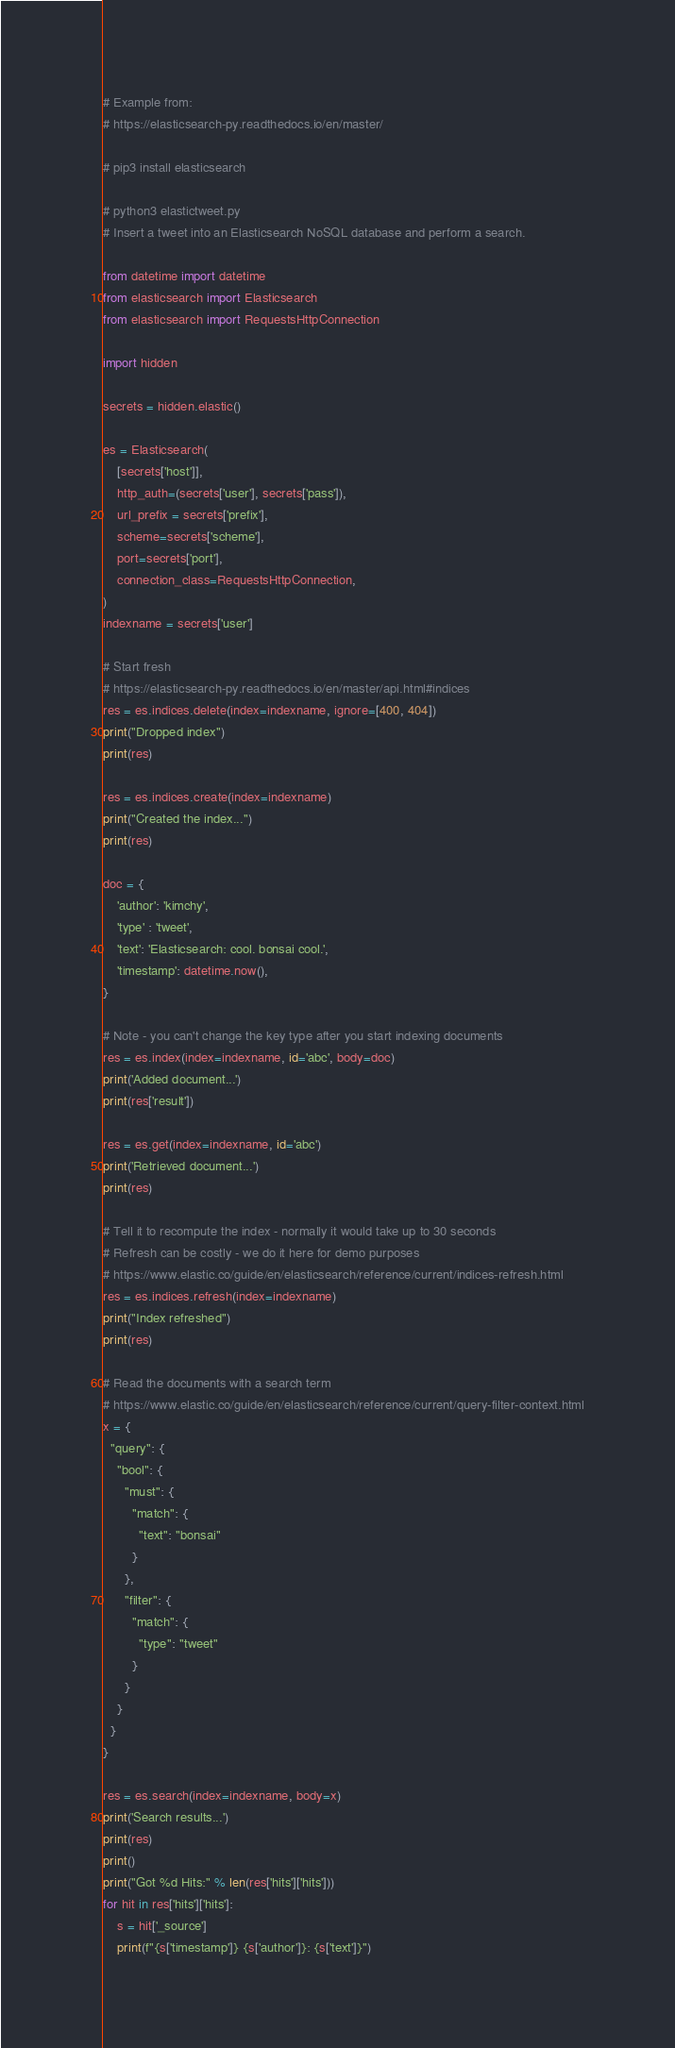<code> <loc_0><loc_0><loc_500><loc_500><_Python_># Example from:
# https://elasticsearch-py.readthedocs.io/en/master/

# pip3 install elasticsearch

# python3 elastictweet.py
# Insert a tweet into an Elasticsearch NoSQL database and perform a search.

from datetime import datetime
from elasticsearch import Elasticsearch
from elasticsearch import RequestsHttpConnection

import hidden

secrets = hidden.elastic()

es = Elasticsearch(
    [secrets['host']],
    http_auth=(secrets['user'], secrets['pass']),
    url_prefix = secrets['prefix'],
    scheme=secrets['scheme'],
    port=secrets['port'],
    connection_class=RequestsHttpConnection,
)
indexname = secrets['user']

# Start fresh
# https://elasticsearch-py.readthedocs.io/en/master/api.html#indices
res = es.indices.delete(index=indexname, ignore=[400, 404])
print("Dropped index")
print(res)

res = es.indices.create(index=indexname)
print("Created the index...")
print(res)

doc = {
    'author': 'kimchy',
    'type' : 'tweet',
    'text': 'Elasticsearch: cool. bonsai cool.',
    'timestamp': datetime.now(),
}

# Note - you can't change the key type after you start indexing documents
res = es.index(index=indexname, id='abc', body=doc)
print('Added document...')
print(res['result'])

res = es.get(index=indexname, id='abc')
print('Retrieved document...')
print(res)

# Tell it to recompute the index - normally it would take up to 30 seconds
# Refresh can be costly - we do it here for demo purposes
# https://www.elastic.co/guide/en/elasticsearch/reference/current/indices-refresh.html
res = es.indices.refresh(index=indexname)
print("Index refreshed")
print(res)

# Read the documents with a search term
# https://www.elastic.co/guide/en/elasticsearch/reference/current/query-filter-context.html
x = {
  "query": {
    "bool": {
      "must": {
        "match": {
          "text": "bonsai"
        }
      },
      "filter": {
        "match": {
          "type": "tweet" 
        }
      }
    }
  }
}

res = es.search(index=indexname, body=x)
print('Search results...')
print(res)
print()
print("Got %d Hits:" % len(res['hits']['hits']))
for hit in res['hits']['hits']:
    s = hit['_source']
    print(f"{s['timestamp']} {s['author']}: {s['text']}")


</code> 